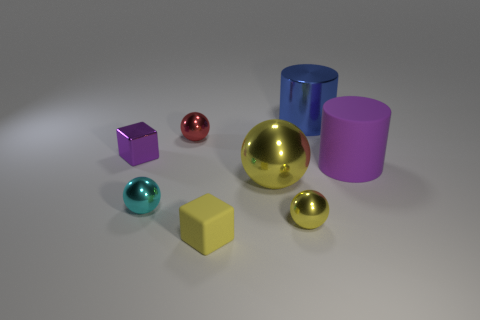Add 2 tiny blue metal cubes. How many objects exist? 10 Subtract all cubes. How many objects are left? 6 Subtract all tiny cyan shiny things. Subtract all big gray matte blocks. How many objects are left? 7 Add 2 tiny yellow balls. How many tiny yellow balls are left? 3 Add 1 yellow objects. How many yellow objects exist? 4 Subtract 1 yellow spheres. How many objects are left? 7 